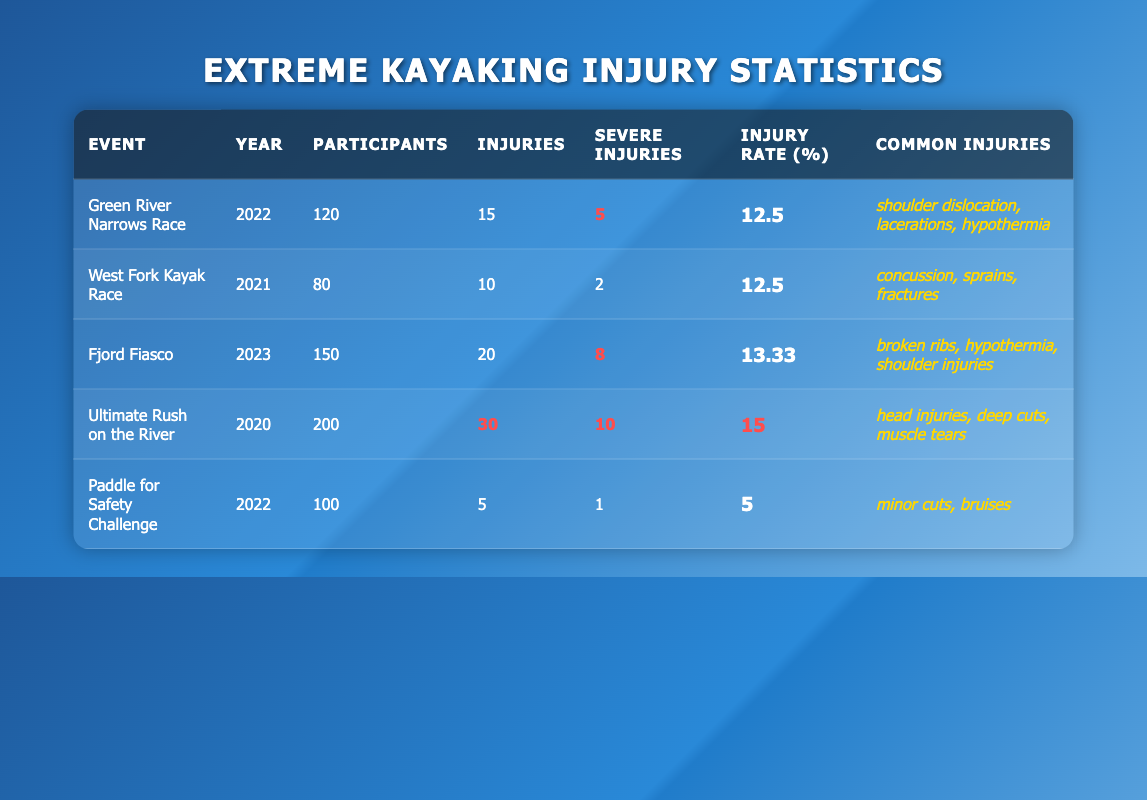What was the injury rate for the Ultimate Rush on the River event? The injury rate for the Ultimate Rush on the River event is listed directly in the table under the "Injury Rate (%)" column as 15.
Answer: 15 How many severe injuries occurred during the Fjord Fiasco? The number of severe injuries for the Fjord Fiasco is highlighted in the table under the "Severe Injuries" column, showing a count of 8.
Answer: 8 Which event had the highest number of total injuries? By comparing the "Injuries" column, the Ultimate Rush on the River event has the highest number at 30, as it is highlighted in the table.
Answer: Ultimate Rush on the River What is the average injury rate across all events included in the table? The injury rates are 12.5, 12.5, 13.33, 15, and 5. Summing these gives 58.33, and dividing by 5 (the number of events) provides an average of 11.67.
Answer: 11.67 Did any event have a lower injury rate than the Paddle for Safety Challenge? The Paddle for Safety Challenge had an injury rate of 5%. Comparing this to the rates for other events, only Paddle for Safety Challenge itself had a lower or equal rate, confirming that no other event was lower.
Answer: No Which common injury was reported in both the Green River Narrows Race and Fjord Fiasco? The common injuries listed for these events include "hypothermia" for both the Green River Narrows Race and Fjord Fiasco, confirming it as a shared common injury.
Answer: Hypothermia What is the difference in the number of participants between the Ultimate Rush on the River and Paddle for Safety Challenge? The Ultimate Rush on the River had 200 participants while the Paddle for Safety Challenge had 100. The difference is calculated as 200 - 100 = 100.
Answer: 100 Was there any event with severe injuries exceeding 10? By reviewing the "Severe Injuries" column, the Ultimate Rush on the River shows 10 severe injuries, but no event exceeds this, so the answer is based on this comparison.
Answer: No 